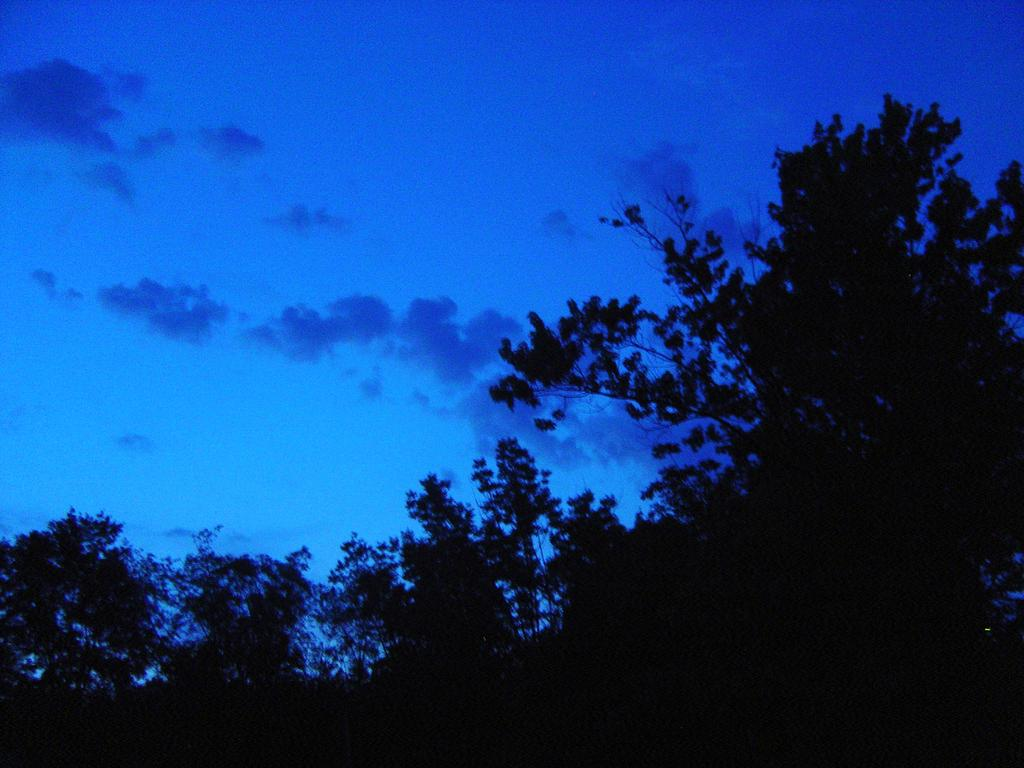What type of vegetation can be seen in the image? There are trees in the image. What part of the natural environment is visible in the image? The sky is visible in the image. Can you see a sign with a horse and a rat on it in the image? There is no sign with a horse and a rat in the image; only trees and the sky are visible. 